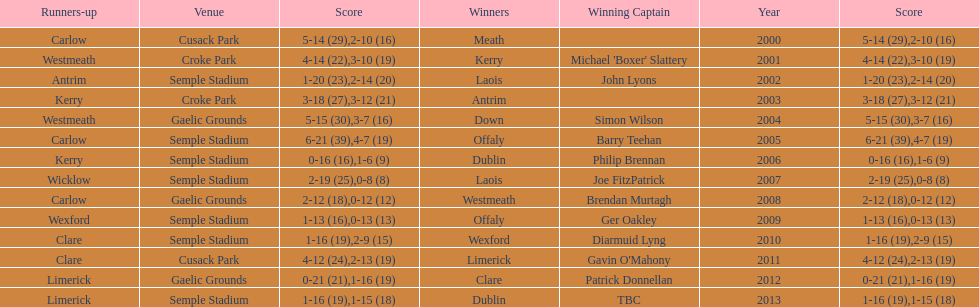Who was the first winning captain? Michael 'Boxer' Slattery. 